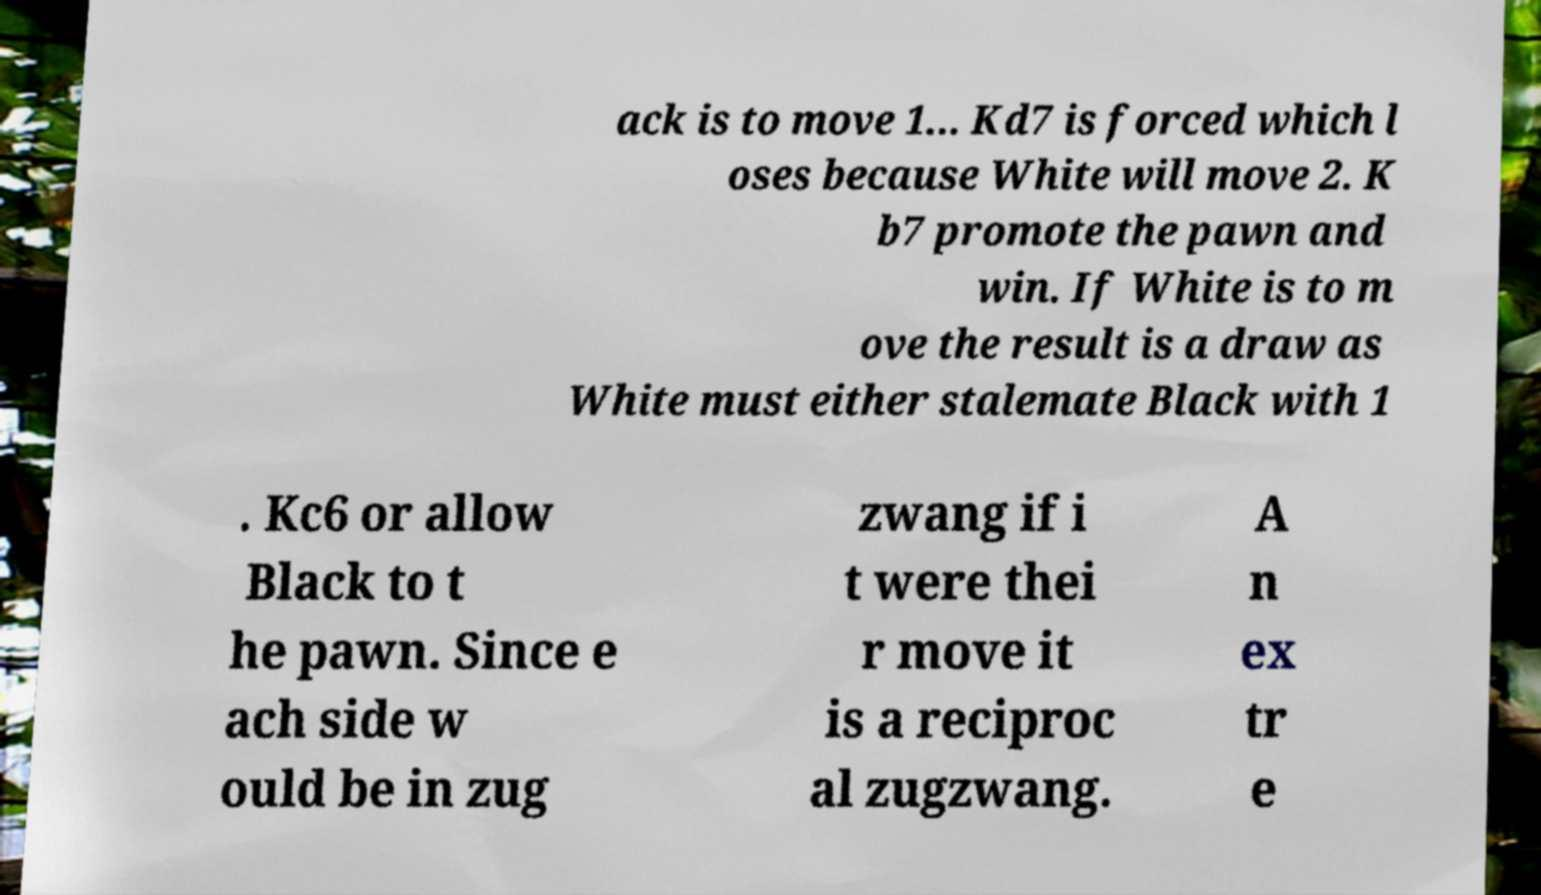Please read and relay the text visible in this image. What does it say? ack is to move 1... Kd7 is forced which l oses because White will move 2. K b7 promote the pawn and win. If White is to m ove the result is a draw as White must either stalemate Black with 1 . Kc6 or allow Black to t he pawn. Since e ach side w ould be in zug zwang if i t were thei r move it is a reciproc al zugzwang. A n ex tr e 